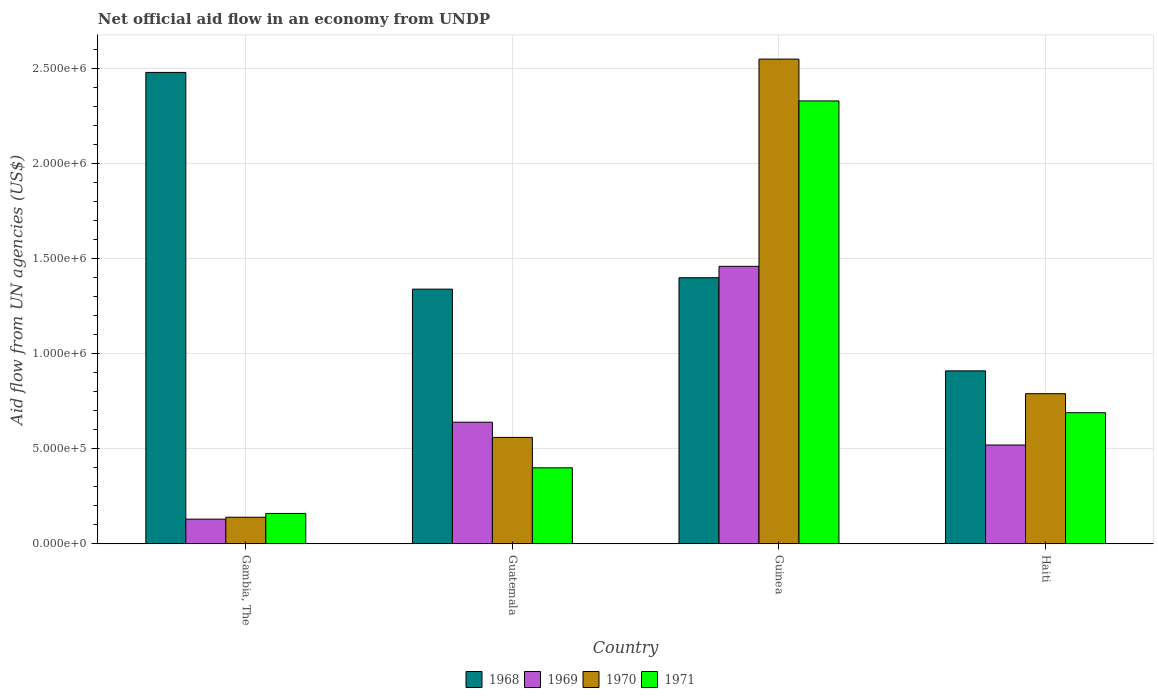How many different coloured bars are there?
Your response must be concise. 4. How many groups of bars are there?
Make the answer very short. 4. Are the number of bars on each tick of the X-axis equal?
Ensure brevity in your answer.  Yes. What is the label of the 4th group of bars from the left?
Ensure brevity in your answer.  Haiti. In how many cases, is the number of bars for a given country not equal to the number of legend labels?
Your answer should be compact. 0. What is the net official aid flow in 1968 in Haiti?
Provide a succinct answer. 9.10e+05. Across all countries, what is the maximum net official aid flow in 1970?
Your answer should be compact. 2.55e+06. Across all countries, what is the minimum net official aid flow in 1969?
Your answer should be very brief. 1.30e+05. In which country was the net official aid flow in 1970 maximum?
Offer a terse response. Guinea. In which country was the net official aid flow in 1971 minimum?
Keep it short and to the point. Gambia, The. What is the total net official aid flow in 1971 in the graph?
Your answer should be very brief. 3.58e+06. What is the difference between the net official aid flow in 1968 in Gambia, The and that in Guinea?
Your answer should be very brief. 1.08e+06. What is the difference between the net official aid flow in 1971 in Guinea and the net official aid flow in 1969 in Guatemala?
Your answer should be very brief. 1.69e+06. What is the average net official aid flow in 1969 per country?
Ensure brevity in your answer.  6.88e+05. What is the difference between the net official aid flow of/in 1968 and net official aid flow of/in 1971 in Guinea?
Give a very brief answer. -9.30e+05. In how many countries, is the net official aid flow in 1968 greater than 1400000 US$?
Your response must be concise. 1. What is the ratio of the net official aid flow in 1970 in Guatemala to that in Haiti?
Your answer should be very brief. 0.71. What is the difference between the highest and the second highest net official aid flow in 1968?
Make the answer very short. 1.14e+06. What is the difference between the highest and the lowest net official aid flow in 1970?
Give a very brief answer. 2.41e+06. In how many countries, is the net official aid flow in 1970 greater than the average net official aid flow in 1970 taken over all countries?
Offer a terse response. 1. Is the sum of the net official aid flow in 1969 in Guatemala and Guinea greater than the maximum net official aid flow in 1970 across all countries?
Offer a terse response. No. Is it the case that in every country, the sum of the net official aid flow in 1971 and net official aid flow in 1970 is greater than the sum of net official aid flow in 1968 and net official aid flow in 1969?
Offer a terse response. No. What does the 1st bar from the left in Guinea represents?
Your response must be concise. 1968. What does the 4th bar from the right in Haiti represents?
Provide a short and direct response. 1968. How many bars are there?
Provide a short and direct response. 16. Are all the bars in the graph horizontal?
Ensure brevity in your answer.  No. How many countries are there in the graph?
Make the answer very short. 4. What is the difference between two consecutive major ticks on the Y-axis?
Give a very brief answer. 5.00e+05. Are the values on the major ticks of Y-axis written in scientific E-notation?
Give a very brief answer. Yes. Does the graph contain grids?
Keep it short and to the point. Yes. How many legend labels are there?
Offer a very short reply. 4. How are the legend labels stacked?
Your response must be concise. Horizontal. What is the title of the graph?
Your answer should be very brief. Net official aid flow in an economy from UNDP. Does "1970" appear as one of the legend labels in the graph?
Offer a very short reply. Yes. What is the label or title of the Y-axis?
Your answer should be compact. Aid flow from UN agencies (US$). What is the Aid flow from UN agencies (US$) of 1968 in Gambia, The?
Offer a very short reply. 2.48e+06. What is the Aid flow from UN agencies (US$) in 1968 in Guatemala?
Keep it short and to the point. 1.34e+06. What is the Aid flow from UN agencies (US$) in 1969 in Guatemala?
Provide a short and direct response. 6.40e+05. What is the Aid flow from UN agencies (US$) of 1970 in Guatemala?
Offer a terse response. 5.60e+05. What is the Aid flow from UN agencies (US$) of 1968 in Guinea?
Keep it short and to the point. 1.40e+06. What is the Aid flow from UN agencies (US$) in 1969 in Guinea?
Your answer should be compact. 1.46e+06. What is the Aid flow from UN agencies (US$) of 1970 in Guinea?
Your answer should be compact. 2.55e+06. What is the Aid flow from UN agencies (US$) of 1971 in Guinea?
Your answer should be compact. 2.33e+06. What is the Aid flow from UN agencies (US$) in 1968 in Haiti?
Provide a short and direct response. 9.10e+05. What is the Aid flow from UN agencies (US$) in 1969 in Haiti?
Offer a very short reply. 5.20e+05. What is the Aid flow from UN agencies (US$) in 1970 in Haiti?
Provide a succinct answer. 7.90e+05. What is the Aid flow from UN agencies (US$) in 1971 in Haiti?
Offer a terse response. 6.90e+05. Across all countries, what is the maximum Aid flow from UN agencies (US$) of 1968?
Offer a very short reply. 2.48e+06. Across all countries, what is the maximum Aid flow from UN agencies (US$) in 1969?
Offer a terse response. 1.46e+06. Across all countries, what is the maximum Aid flow from UN agencies (US$) of 1970?
Your answer should be very brief. 2.55e+06. Across all countries, what is the maximum Aid flow from UN agencies (US$) of 1971?
Your answer should be very brief. 2.33e+06. Across all countries, what is the minimum Aid flow from UN agencies (US$) in 1968?
Offer a terse response. 9.10e+05. Across all countries, what is the minimum Aid flow from UN agencies (US$) of 1969?
Offer a very short reply. 1.30e+05. Across all countries, what is the minimum Aid flow from UN agencies (US$) of 1971?
Make the answer very short. 1.60e+05. What is the total Aid flow from UN agencies (US$) of 1968 in the graph?
Keep it short and to the point. 6.13e+06. What is the total Aid flow from UN agencies (US$) of 1969 in the graph?
Your answer should be compact. 2.75e+06. What is the total Aid flow from UN agencies (US$) in 1970 in the graph?
Keep it short and to the point. 4.04e+06. What is the total Aid flow from UN agencies (US$) of 1971 in the graph?
Provide a succinct answer. 3.58e+06. What is the difference between the Aid flow from UN agencies (US$) in 1968 in Gambia, The and that in Guatemala?
Keep it short and to the point. 1.14e+06. What is the difference between the Aid flow from UN agencies (US$) of 1969 in Gambia, The and that in Guatemala?
Keep it short and to the point. -5.10e+05. What is the difference between the Aid flow from UN agencies (US$) of 1970 in Gambia, The and that in Guatemala?
Keep it short and to the point. -4.20e+05. What is the difference between the Aid flow from UN agencies (US$) in 1968 in Gambia, The and that in Guinea?
Your response must be concise. 1.08e+06. What is the difference between the Aid flow from UN agencies (US$) in 1969 in Gambia, The and that in Guinea?
Provide a short and direct response. -1.33e+06. What is the difference between the Aid flow from UN agencies (US$) of 1970 in Gambia, The and that in Guinea?
Your response must be concise. -2.41e+06. What is the difference between the Aid flow from UN agencies (US$) of 1971 in Gambia, The and that in Guinea?
Offer a terse response. -2.17e+06. What is the difference between the Aid flow from UN agencies (US$) of 1968 in Gambia, The and that in Haiti?
Make the answer very short. 1.57e+06. What is the difference between the Aid flow from UN agencies (US$) of 1969 in Gambia, The and that in Haiti?
Offer a very short reply. -3.90e+05. What is the difference between the Aid flow from UN agencies (US$) in 1970 in Gambia, The and that in Haiti?
Offer a very short reply. -6.50e+05. What is the difference between the Aid flow from UN agencies (US$) in 1971 in Gambia, The and that in Haiti?
Your answer should be very brief. -5.30e+05. What is the difference between the Aid flow from UN agencies (US$) in 1969 in Guatemala and that in Guinea?
Keep it short and to the point. -8.20e+05. What is the difference between the Aid flow from UN agencies (US$) in 1970 in Guatemala and that in Guinea?
Provide a succinct answer. -1.99e+06. What is the difference between the Aid flow from UN agencies (US$) in 1971 in Guatemala and that in Guinea?
Give a very brief answer. -1.93e+06. What is the difference between the Aid flow from UN agencies (US$) in 1969 in Guatemala and that in Haiti?
Provide a succinct answer. 1.20e+05. What is the difference between the Aid flow from UN agencies (US$) in 1971 in Guatemala and that in Haiti?
Offer a very short reply. -2.90e+05. What is the difference between the Aid flow from UN agencies (US$) of 1968 in Guinea and that in Haiti?
Provide a succinct answer. 4.90e+05. What is the difference between the Aid flow from UN agencies (US$) of 1969 in Guinea and that in Haiti?
Offer a very short reply. 9.40e+05. What is the difference between the Aid flow from UN agencies (US$) in 1970 in Guinea and that in Haiti?
Your response must be concise. 1.76e+06. What is the difference between the Aid flow from UN agencies (US$) in 1971 in Guinea and that in Haiti?
Provide a succinct answer. 1.64e+06. What is the difference between the Aid flow from UN agencies (US$) of 1968 in Gambia, The and the Aid flow from UN agencies (US$) of 1969 in Guatemala?
Your answer should be very brief. 1.84e+06. What is the difference between the Aid flow from UN agencies (US$) of 1968 in Gambia, The and the Aid flow from UN agencies (US$) of 1970 in Guatemala?
Ensure brevity in your answer.  1.92e+06. What is the difference between the Aid flow from UN agencies (US$) of 1968 in Gambia, The and the Aid flow from UN agencies (US$) of 1971 in Guatemala?
Keep it short and to the point. 2.08e+06. What is the difference between the Aid flow from UN agencies (US$) in 1969 in Gambia, The and the Aid flow from UN agencies (US$) in 1970 in Guatemala?
Keep it short and to the point. -4.30e+05. What is the difference between the Aid flow from UN agencies (US$) in 1969 in Gambia, The and the Aid flow from UN agencies (US$) in 1971 in Guatemala?
Your answer should be very brief. -2.70e+05. What is the difference between the Aid flow from UN agencies (US$) in 1970 in Gambia, The and the Aid flow from UN agencies (US$) in 1971 in Guatemala?
Provide a short and direct response. -2.60e+05. What is the difference between the Aid flow from UN agencies (US$) in 1968 in Gambia, The and the Aid flow from UN agencies (US$) in 1969 in Guinea?
Offer a very short reply. 1.02e+06. What is the difference between the Aid flow from UN agencies (US$) of 1969 in Gambia, The and the Aid flow from UN agencies (US$) of 1970 in Guinea?
Offer a very short reply. -2.42e+06. What is the difference between the Aid flow from UN agencies (US$) of 1969 in Gambia, The and the Aid flow from UN agencies (US$) of 1971 in Guinea?
Your answer should be compact. -2.20e+06. What is the difference between the Aid flow from UN agencies (US$) in 1970 in Gambia, The and the Aid flow from UN agencies (US$) in 1971 in Guinea?
Provide a short and direct response. -2.19e+06. What is the difference between the Aid flow from UN agencies (US$) of 1968 in Gambia, The and the Aid flow from UN agencies (US$) of 1969 in Haiti?
Provide a succinct answer. 1.96e+06. What is the difference between the Aid flow from UN agencies (US$) of 1968 in Gambia, The and the Aid flow from UN agencies (US$) of 1970 in Haiti?
Your answer should be compact. 1.69e+06. What is the difference between the Aid flow from UN agencies (US$) in 1968 in Gambia, The and the Aid flow from UN agencies (US$) in 1971 in Haiti?
Provide a succinct answer. 1.79e+06. What is the difference between the Aid flow from UN agencies (US$) of 1969 in Gambia, The and the Aid flow from UN agencies (US$) of 1970 in Haiti?
Provide a short and direct response. -6.60e+05. What is the difference between the Aid flow from UN agencies (US$) in 1969 in Gambia, The and the Aid flow from UN agencies (US$) in 1971 in Haiti?
Your answer should be compact. -5.60e+05. What is the difference between the Aid flow from UN agencies (US$) in 1970 in Gambia, The and the Aid flow from UN agencies (US$) in 1971 in Haiti?
Your answer should be very brief. -5.50e+05. What is the difference between the Aid flow from UN agencies (US$) of 1968 in Guatemala and the Aid flow from UN agencies (US$) of 1970 in Guinea?
Give a very brief answer. -1.21e+06. What is the difference between the Aid flow from UN agencies (US$) of 1968 in Guatemala and the Aid flow from UN agencies (US$) of 1971 in Guinea?
Provide a succinct answer. -9.90e+05. What is the difference between the Aid flow from UN agencies (US$) of 1969 in Guatemala and the Aid flow from UN agencies (US$) of 1970 in Guinea?
Keep it short and to the point. -1.91e+06. What is the difference between the Aid flow from UN agencies (US$) in 1969 in Guatemala and the Aid flow from UN agencies (US$) in 1971 in Guinea?
Provide a short and direct response. -1.69e+06. What is the difference between the Aid flow from UN agencies (US$) of 1970 in Guatemala and the Aid flow from UN agencies (US$) of 1971 in Guinea?
Your answer should be very brief. -1.77e+06. What is the difference between the Aid flow from UN agencies (US$) of 1968 in Guatemala and the Aid flow from UN agencies (US$) of 1969 in Haiti?
Provide a succinct answer. 8.20e+05. What is the difference between the Aid flow from UN agencies (US$) in 1968 in Guatemala and the Aid flow from UN agencies (US$) in 1971 in Haiti?
Make the answer very short. 6.50e+05. What is the difference between the Aid flow from UN agencies (US$) of 1969 in Guatemala and the Aid flow from UN agencies (US$) of 1970 in Haiti?
Keep it short and to the point. -1.50e+05. What is the difference between the Aid flow from UN agencies (US$) in 1968 in Guinea and the Aid flow from UN agencies (US$) in 1969 in Haiti?
Your answer should be very brief. 8.80e+05. What is the difference between the Aid flow from UN agencies (US$) in 1968 in Guinea and the Aid flow from UN agencies (US$) in 1970 in Haiti?
Provide a short and direct response. 6.10e+05. What is the difference between the Aid flow from UN agencies (US$) in 1968 in Guinea and the Aid flow from UN agencies (US$) in 1971 in Haiti?
Keep it short and to the point. 7.10e+05. What is the difference between the Aid flow from UN agencies (US$) of 1969 in Guinea and the Aid flow from UN agencies (US$) of 1970 in Haiti?
Keep it short and to the point. 6.70e+05. What is the difference between the Aid flow from UN agencies (US$) of 1969 in Guinea and the Aid flow from UN agencies (US$) of 1971 in Haiti?
Offer a terse response. 7.70e+05. What is the difference between the Aid flow from UN agencies (US$) of 1970 in Guinea and the Aid flow from UN agencies (US$) of 1971 in Haiti?
Make the answer very short. 1.86e+06. What is the average Aid flow from UN agencies (US$) in 1968 per country?
Offer a very short reply. 1.53e+06. What is the average Aid flow from UN agencies (US$) of 1969 per country?
Give a very brief answer. 6.88e+05. What is the average Aid flow from UN agencies (US$) in 1970 per country?
Your answer should be very brief. 1.01e+06. What is the average Aid flow from UN agencies (US$) of 1971 per country?
Provide a succinct answer. 8.95e+05. What is the difference between the Aid flow from UN agencies (US$) in 1968 and Aid flow from UN agencies (US$) in 1969 in Gambia, The?
Your response must be concise. 2.35e+06. What is the difference between the Aid flow from UN agencies (US$) of 1968 and Aid flow from UN agencies (US$) of 1970 in Gambia, The?
Offer a terse response. 2.34e+06. What is the difference between the Aid flow from UN agencies (US$) of 1968 and Aid flow from UN agencies (US$) of 1971 in Gambia, The?
Provide a succinct answer. 2.32e+06. What is the difference between the Aid flow from UN agencies (US$) in 1969 and Aid flow from UN agencies (US$) in 1971 in Gambia, The?
Offer a very short reply. -3.00e+04. What is the difference between the Aid flow from UN agencies (US$) in 1970 and Aid flow from UN agencies (US$) in 1971 in Gambia, The?
Offer a very short reply. -2.00e+04. What is the difference between the Aid flow from UN agencies (US$) in 1968 and Aid flow from UN agencies (US$) in 1969 in Guatemala?
Offer a terse response. 7.00e+05. What is the difference between the Aid flow from UN agencies (US$) in 1968 and Aid flow from UN agencies (US$) in 1970 in Guatemala?
Provide a short and direct response. 7.80e+05. What is the difference between the Aid flow from UN agencies (US$) in 1968 and Aid flow from UN agencies (US$) in 1971 in Guatemala?
Ensure brevity in your answer.  9.40e+05. What is the difference between the Aid flow from UN agencies (US$) of 1969 and Aid flow from UN agencies (US$) of 1970 in Guatemala?
Keep it short and to the point. 8.00e+04. What is the difference between the Aid flow from UN agencies (US$) of 1968 and Aid flow from UN agencies (US$) of 1970 in Guinea?
Offer a terse response. -1.15e+06. What is the difference between the Aid flow from UN agencies (US$) in 1968 and Aid flow from UN agencies (US$) in 1971 in Guinea?
Your response must be concise. -9.30e+05. What is the difference between the Aid flow from UN agencies (US$) in 1969 and Aid flow from UN agencies (US$) in 1970 in Guinea?
Your answer should be compact. -1.09e+06. What is the difference between the Aid flow from UN agencies (US$) of 1969 and Aid flow from UN agencies (US$) of 1971 in Guinea?
Provide a succinct answer. -8.70e+05. What is the difference between the Aid flow from UN agencies (US$) in 1969 and Aid flow from UN agencies (US$) in 1970 in Haiti?
Keep it short and to the point. -2.70e+05. What is the ratio of the Aid flow from UN agencies (US$) of 1968 in Gambia, The to that in Guatemala?
Your answer should be very brief. 1.85. What is the ratio of the Aid flow from UN agencies (US$) in 1969 in Gambia, The to that in Guatemala?
Ensure brevity in your answer.  0.2. What is the ratio of the Aid flow from UN agencies (US$) of 1970 in Gambia, The to that in Guatemala?
Your answer should be compact. 0.25. What is the ratio of the Aid flow from UN agencies (US$) in 1971 in Gambia, The to that in Guatemala?
Ensure brevity in your answer.  0.4. What is the ratio of the Aid flow from UN agencies (US$) of 1968 in Gambia, The to that in Guinea?
Keep it short and to the point. 1.77. What is the ratio of the Aid flow from UN agencies (US$) of 1969 in Gambia, The to that in Guinea?
Your answer should be compact. 0.09. What is the ratio of the Aid flow from UN agencies (US$) of 1970 in Gambia, The to that in Guinea?
Your answer should be compact. 0.05. What is the ratio of the Aid flow from UN agencies (US$) of 1971 in Gambia, The to that in Guinea?
Give a very brief answer. 0.07. What is the ratio of the Aid flow from UN agencies (US$) of 1968 in Gambia, The to that in Haiti?
Your response must be concise. 2.73. What is the ratio of the Aid flow from UN agencies (US$) of 1970 in Gambia, The to that in Haiti?
Your answer should be compact. 0.18. What is the ratio of the Aid flow from UN agencies (US$) of 1971 in Gambia, The to that in Haiti?
Provide a short and direct response. 0.23. What is the ratio of the Aid flow from UN agencies (US$) of 1968 in Guatemala to that in Guinea?
Provide a succinct answer. 0.96. What is the ratio of the Aid flow from UN agencies (US$) in 1969 in Guatemala to that in Guinea?
Provide a succinct answer. 0.44. What is the ratio of the Aid flow from UN agencies (US$) in 1970 in Guatemala to that in Guinea?
Ensure brevity in your answer.  0.22. What is the ratio of the Aid flow from UN agencies (US$) of 1971 in Guatemala to that in Guinea?
Make the answer very short. 0.17. What is the ratio of the Aid flow from UN agencies (US$) of 1968 in Guatemala to that in Haiti?
Keep it short and to the point. 1.47. What is the ratio of the Aid flow from UN agencies (US$) in 1969 in Guatemala to that in Haiti?
Make the answer very short. 1.23. What is the ratio of the Aid flow from UN agencies (US$) of 1970 in Guatemala to that in Haiti?
Offer a very short reply. 0.71. What is the ratio of the Aid flow from UN agencies (US$) of 1971 in Guatemala to that in Haiti?
Ensure brevity in your answer.  0.58. What is the ratio of the Aid flow from UN agencies (US$) of 1968 in Guinea to that in Haiti?
Offer a terse response. 1.54. What is the ratio of the Aid flow from UN agencies (US$) of 1969 in Guinea to that in Haiti?
Your answer should be compact. 2.81. What is the ratio of the Aid flow from UN agencies (US$) of 1970 in Guinea to that in Haiti?
Your response must be concise. 3.23. What is the ratio of the Aid flow from UN agencies (US$) in 1971 in Guinea to that in Haiti?
Ensure brevity in your answer.  3.38. What is the difference between the highest and the second highest Aid flow from UN agencies (US$) of 1968?
Provide a succinct answer. 1.08e+06. What is the difference between the highest and the second highest Aid flow from UN agencies (US$) in 1969?
Provide a short and direct response. 8.20e+05. What is the difference between the highest and the second highest Aid flow from UN agencies (US$) in 1970?
Your answer should be compact. 1.76e+06. What is the difference between the highest and the second highest Aid flow from UN agencies (US$) in 1971?
Make the answer very short. 1.64e+06. What is the difference between the highest and the lowest Aid flow from UN agencies (US$) of 1968?
Keep it short and to the point. 1.57e+06. What is the difference between the highest and the lowest Aid flow from UN agencies (US$) of 1969?
Your response must be concise. 1.33e+06. What is the difference between the highest and the lowest Aid flow from UN agencies (US$) in 1970?
Give a very brief answer. 2.41e+06. What is the difference between the highest and the lowest Aid flow from UN agencies (US$) in 1971?
Keep it short and to the point. 2.17e+06. 